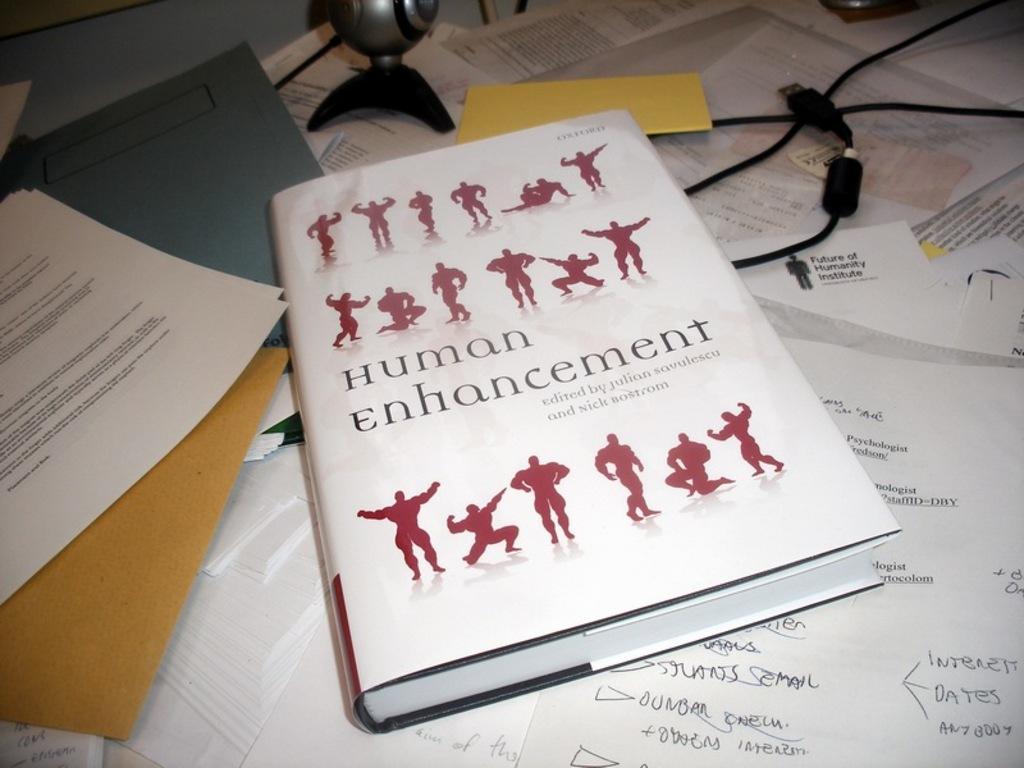Can you describe this image briefly? In this image there are papers with some text, book, files, cables and few other objects on the table. 